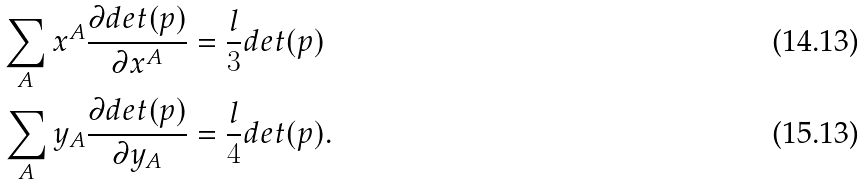Convert formula to latex. <formula><loc_0><loc_0><loc_500><loc_500>\sum _ { A } x ^ { A } \frac { \partial d e t ( p ) } { \partial x ^ { A } } & = \frac { l } { 3 } d e t ( p ) \\ \sum _ { A } y _ { A } \frac { \partial d e t ( p ) } { \partial y _ { A } } & = \frac { l } { 4 } d e t ( p ) .</formula> 